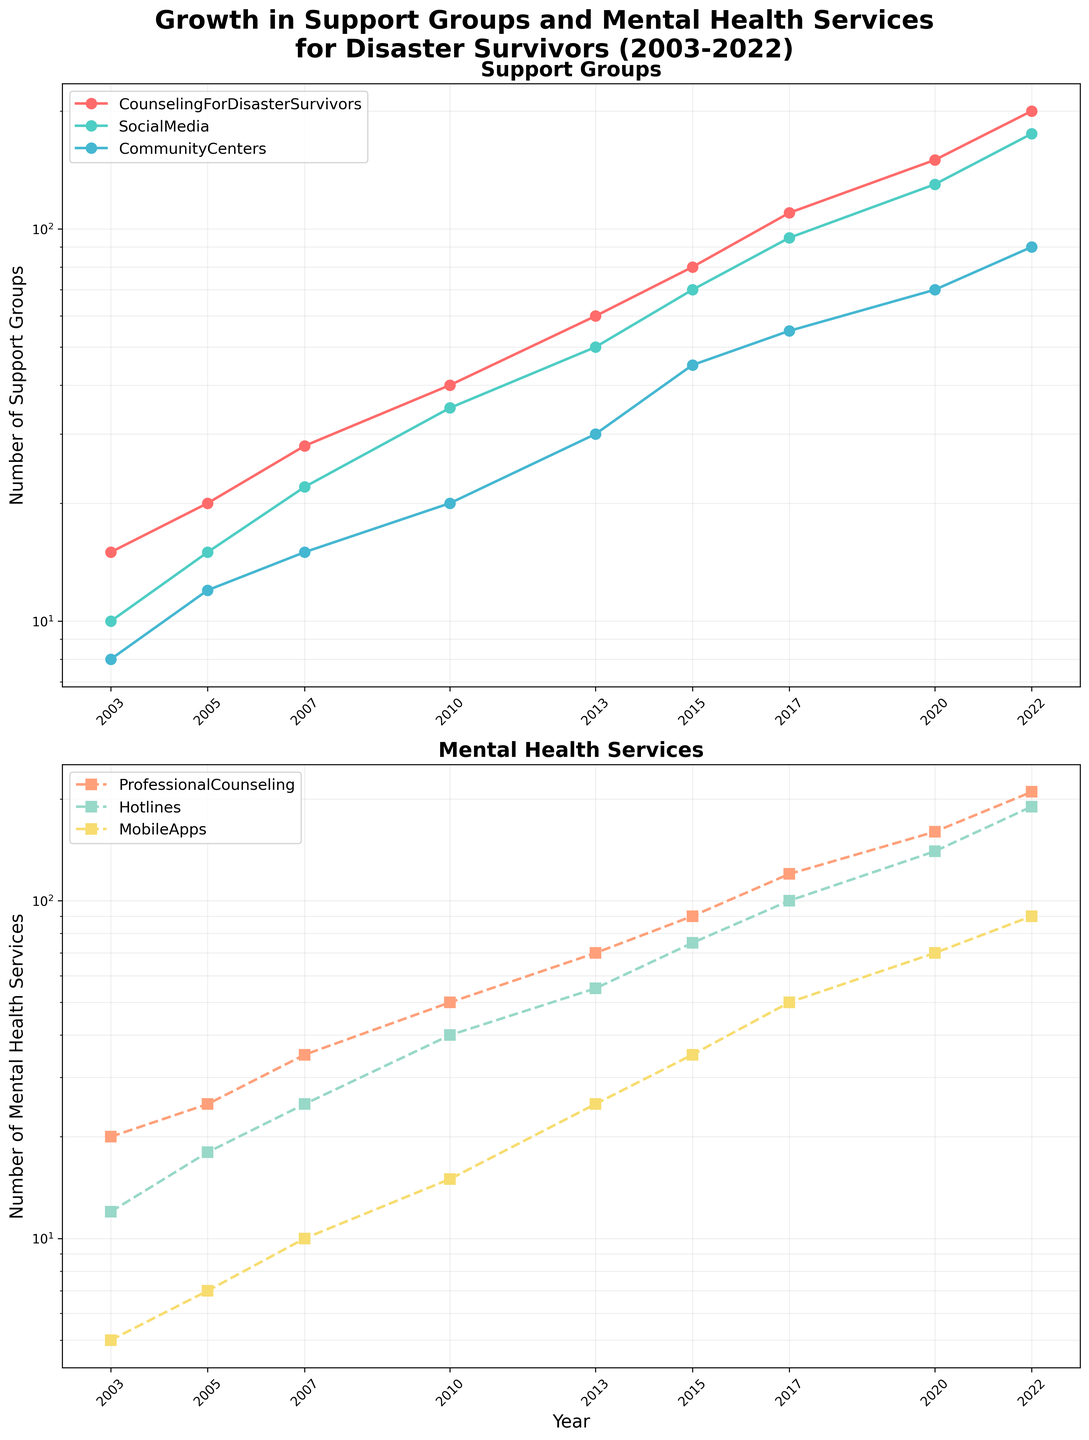Which support group has the highest number in 2022? Look for the highest data point in the Support Groups subplot for the year 2022. According to the figure, the Support Group via Social Media has the highest value with 175.
Answer: Support Group via Social Media How does the growth of Professional Counseling compare to Mobile Apps in terms of the number of services offered over the last two decades? In the Mental Health Services subplot, Professional Counseling starts at 20 in 2003 and reaches 210 in 2022, while Mobile Apps start at 5 and reach 90 in the same period. Professional Counseling shows a more significant increase than Mobile Apps.
Answer: Professional Counseling shows a more significant increase What year do Support Group via Community Centers first surpass 50? Look in the Support Groups subplot for the Community Centers line and find the first time it surpasses the 50 mark, which is around 2017.
Answer: 2017 What is the difference in the number of Social Media Support Groups and Hotlines in 2017? Find the values for Social Media Support Groups and Hotlines in 2017 in their respective subplots. Social Media Support Groups are 95, and Hotlines are 100. The difference is 100 - 95 = 5.
Answer: 5 Which Mental Health Service shows the least growth over the period? By examining the slopes of the lines in the Mental Health Services subplot, it is evident that Mobile Apps show the least growth, starting at 5 and increasing to 90.
Answer: Mobile Apps What is the average number of Support Group by Social Media from 2003 to 2022? Sum up the values for Social Media in the Support Groups subplot for all years and divide by the number of years. (10 + 15 + 22 + 35 + 50 + 70 + 95 + 130 + 175) / 9 provides approximately 66.44.
Answer: 66.44 Is there any year where all three Mental Health Services showed an equal increase rate? By assessing the lines in the Mental Health Services subplot, the lines never show equal or parallel increases in the same year.
Answer: No Which category shows the steepest rise between 2010 and 2020? Compare the slopes of the lines between 2010 and 2020 in both subplots. Support Group via Social Media rises from 35 to 130, presenting the steepest rise among all.
Answer: Support Group via Social Media How many more Support Groups via Counseling existed in 2010 compared to 2005? Look at the values for Counseling in the Support Groups subplot for 2010 and 2005. The difference is 40 - 20 = 20.
Answer: 20 